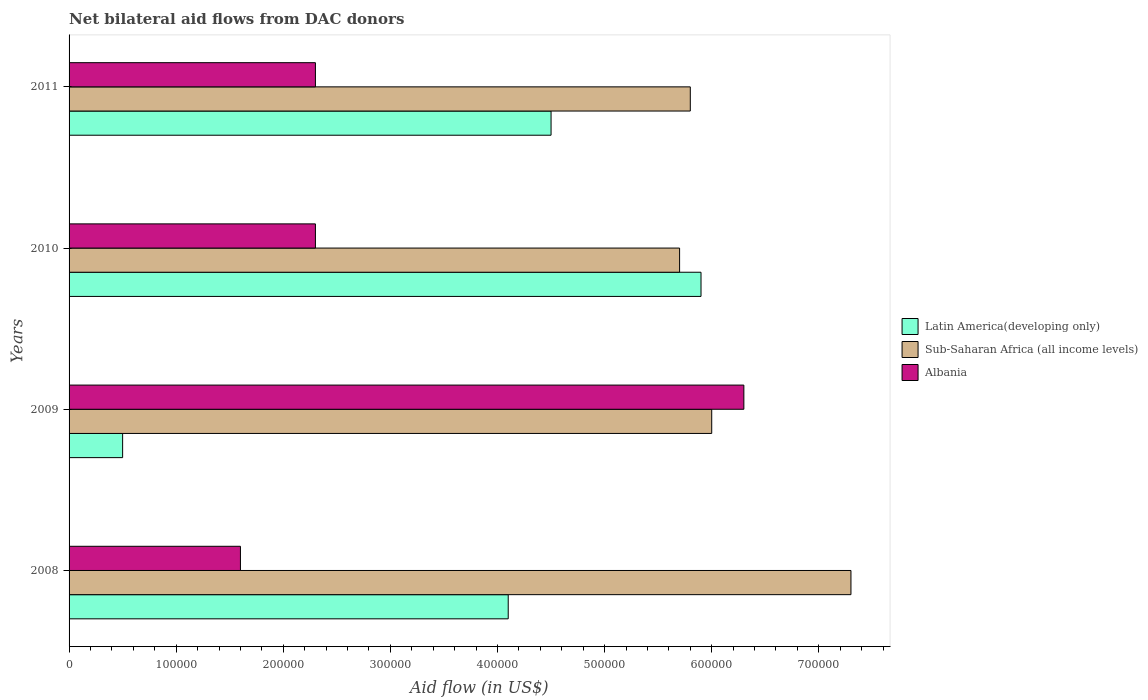Are the number of bars on each tick of the Y-axis equal?
Give a very brief answer. Yes. What is the label of the 2nd group of bars from the top?
Provide a succinct answer. 2010. What is the net bilateral aid flow in Latin America(developing only) in 2008?
Provide a succinct answer. 4.10e+05. Across all years, what is the maximum net bilateral aid flow in Latin America(developing only)?
Your answer should be compact. 5.90e+05. Across all years, what is the minimum net bilateral aid flow in Albania?
Provide a short and direct response. 1.60e+05. In which year was the net bilateral aid flow in Sub-Saharan Africa (all income levels) maximum?
Provide a short and direct response. 2008. What is the total net bilateral aid flow in Sub-Saharan Africa (all income levels) in the graph?
Offer a terse response. 2.48e+06. What is the difference between the net bilateral aid flow in Latin America(developing only) in 2008 and that in 2011?
Provide a short and direct response. -4.00e+04. What is the difference between the net bilateral aid flow in Latin America(developing only) in 2009 and the net bilateral aid flow in Albania in 2008?
Ensure brevity in your answer.  -1.10e+05. What is the average net bilateral aid flow in Sub-Saharan Africa (all income levels) per year?
Give a very brief answer. 6.20e+05. In the year 2008, what is the difference between the net bilateral aid flow in Latin America(developing only) and net bilateral aid flow in Albania?
Give a very brief answer. 2.50e+05. What is the ratio of the net bilateral aid flow in Latin America(developing only) in 2010 to that in 2011?
Offer a terse response. 1.31. Is the net bilateral aid flow in Albania in 2009 less than that in 2010?
Your answer should be very brief. No. Is the difference between the net bilateral aid flow in Latin America(developing only) in 2008 and 2010 greater than the difference between the net bilateral aid flow in Albania in 2008 and 2010?
Your response must be concise. No. What is the difference between the highest and the lowest net bilateral aid flow in Sub-Saharan Africa (all income levels)?
Your response must be concise. 1.60e+05. In how many years, is the net bilateral aid flow in Sub-Saharan Africa (all income levels) greater than the average net bilateral aid flow in Sub-Saharan Africa (all income levels) taken over all years?
Offer a terse response. 1. What does the 2nd bar from the top in 2008 represents?
Your answer should be compact. Sub-Saharan Africa (all income levels). What does the 3rd bar from the bottom in 2010 represents?
Your answer should be very brief. Albania. How many bars are there?
Your response must be concise. 12. Are all the bars in the graph horizontal?
Provide a short and direct response. Yes. Where does the legend appear in the graph?
Provide a succinct answer. Center right. What is the title of the graph?
Offer a terse response. Net bilateral aid flows from DAC donors. What is the label or title of the X-axis?
Offer a very short reply. Aid flow (in US$). What is the Aid flow (in US$) in Latin America(developing only) in 2008?
Ensure brevity in your answer.  4.10e+05. What is the Aid flow (in US$) in Sub-Saharan Africa (all income levels) in 2008?
Provide a succinct answer. 7.30e+05. What is the Aid flow (in US$) in Latin America(developing only) in 2009?
Make the answer very short. 5.00e+04. What is the Aid flow (in US$) in Sub-Saharan Africa (all income levels) in 2009?
Offer a terse response. 6.00e+05. What is the Aid flow (in US$) of Albania in 2009?
Ensure brevity in your answer.  6.30e+05. What is the Aid flow (in US$) of Latin America(developing only) in 2010?
Provide a succinct answer. 5.90e+05. What is the Aid flow (in US$) of Sub-Saharan Africa (all income levels) in 2010?
Offer a terse response. 5.70e+05. What is the Aid flow (in US$) of Sub-Saharan Africa (all income levels) in 2011?
Offer a terse response. 5.80e+05. What is the Aid flow (in US$) of Albania in 2011?
Your answer should be very brief. 2.30e+05. Across all years, what is the maximum Aid flow (in US$) of Latin America(developing only)?
Offer a very short reply. 5.90e+05. Across all years, what is the maximum Aid flow (in US$) in Sub-Saharan Africa (all income levels)?
Your response must be concise. 7.30e+05. Across all years, what is the maximum Aid flow (in US$) in Albania?
Ensure brevity in your answer.  6.30e+05. Across all years, what is the minimum Aid flow (in US$) in Sub-Saharan Africa (all income levels)?
Provide a short and direct response. 5.70e+05. Across all years, what is the minimum Aid flow (in US$) in Albania?
Your response must be concise. 1.60e+05. What is the total Aid flow (in US$) in Latin America(developing only) in the graph?
Make the answer very short. 1.50e+06. What is the total Aid flow (in US$) in Sub-Saharan Africa (all income levels) in the graph?
Make the answer very short. 2.48e+06. What is the total Aid flow (in US$) in Albania in the graph?
Make the answer very short. 1.25e+06. What is the difference between the Aid flow (in US$) of Latin America(developing only) in 2008 and that in 2009?
Give a very brief answer. 3.60e+05. What is the difference between the Aid flow (in US$) in Albania in 2008 and that in 2009?
Offer a terse response. -4.70e+05. What is the difference between the Aid flow (in US$) of Sub-Saharan Africa (all income levels) in 2008 and that in 2010?
Provide a succinct answer. 1.60e+05. What is the difference between the Aid flow (in US$) of Albania in 2008 and that in 2011?
Provide a short and direct response. -7.00e+04. What is the difference between the Aid flow (in US$) of Latin America(developing only) in 2009 and that in 2010?
Your answer should be compact. -5.40e+05. What is the difference between the Aid flow (in US$) in Albania in 2009 and that in 2010?
Make the answer very short. 4.00e+05. What is the difference between the Aid flow (in US$) of Latin America(developing only) in 2009 and that in 2011?
Provide a succinct answer. -4.00e+05. What is the difference between the Aid flow (in US$) of Sub-Saharan Africa (all income levels) in 2009 and that in 2011?
Your response must be concise. 2.00e+04. What is the difference between the Aid flow (in US$) in Albania in 2009 and that in 2011?
Provide a short and direct response. 4.00e+05. What is the difference between the Aid flow (in US$) of Latin America(developing only) in 2010 and that in 2011?
Keep it short and to the point. 1.40e+05. What is the difference between the Aid flow (in US$) in Sub-Saharan Africa (all income levels) in 2010 and that in 2011?
Offer a very short reply. -10000. What is the difference between the Aid flow (in US$) of Albania in 2010 and that in 2011?
Your answer should be very brief. 0. What is the difference between the Aid flow (in US$) of Sub-Saharan Africa (all income levels) in 2008 and the Aid flow (in US$) of Albania in 2009?
Make the answer very short. 1.00e+05. What is the difference between the Aid flow (in US$) in Latin America(developing only) in 2008 and the Aid flow (in US$) in Sub-Saharan Africa (all income levels) in 2010?
Provide a succinct answer. -1.60e+05. What is the difference between the Aid flow (in US$) in Sub-Saharan Africa (all income levels) in 2008 and the Aid flow (in US$) in Albania in 2010?
Give a very brief answer. 5.00e+05. What is the difference between the Aid flow (in US$) of Latin America(developing only) in 2008 and the Aid flow (in US$) of Albania in 2011?
Your response must be concise. 1.80e+05. What is the difference between the Aid flow (in US$) in Sub-Saharan Africa (all income levels) in 2008 and the Aid flow (in US$) in Albania in 2011?
Ensure brevity in your answer.  5.00e+05. What is the difference between the Aid flow (in US$) in Latin America(developing only) in 2009 and the Aid flow (in US$) in Sub-Saharan Africa (all income levels) in 2010?
Your response must be concise. -5.20e+05. What is the difference between the Aid flow (in US$) in Sub-Saharan Africa (all income levels) in 2009 and the Aid flow (in US$) in Albania in 2010?
Provide a succinct answer. 3.70e+05. What is the difference between the Aid flow (in US$) in Latin America(developing only) in 2009 and the Aid flow (in US$) in Sub-Saharan Africa (all income levels) in 2011?
Keep it short and to the point. -5.30e+05. What is the difference between the Aid flow (in US$) of Latin America(developing only) in 2009 and the Aid flow (in US$) of Albania in 2011?
Your answer should be very brief. -1.80e+05. What is the difference between the Aid flow (in US$) of Latin America(developing only) in 2010 and the Aid flow (in US$) of Sub-Saharan Africa (all income levels) in 2011?
Provide a succinct answer. 10000. What is the difference between the Aid flow (in US$) of Sub-Saharan Africa (all income levels) in 2010 and the Aid flow (in US$) of Albania in 2011?
Your answer should be compact. 3.40e+05. What is the average Aid flow (in US$) in Latin America(developing only) per year?
Offer a terse response. 3.75e+05. What is the average Aid flow (in US$) of Sub-Saharan Africa (all income levels) per year?
Your answer should be compact. 6.20e+05. What is the average Aid flow (in US$) in Albania per year?
Your answer should be compact. 3.12e+05. In the year 2008, what is the difference between the Aid flow (in US$) of Latin America(developing only) and Aid flow (in US$) of Sub-Saharan Africa (all income levels)?
Provide a succinct answer. -3.20e+05. In the year 2008, what is the difference between the Aid flow (in US$) of Sub-Saharan Africa (all income levels) and Aid flow (in US$) of Albania?
Your answer should be very brief. 5.70e+05. In the year 2009, what is the difference between the Aid flow (in US$) in Latin America(developing only) and Aid flow (in US$) in Sub-Saharan Africa (all income levels)?
Give a very brief answer. -5.50e+05. In the year 2009, what is the difference between the Aid flow (in US$) of Latin America(developing only) and Aid flow (in US$) of Albania?
Provide a short and direct response. -5.80e+05. In the year 2011, what is the difference between the Aid flow (in US$) in Latin America(developing only) and Aid flow (in US$) in Sub-Saharan Africa (all income levels)?
Your answer should be very brief. -1.30e+05. In the year 2011, what is the difference between the Aid flow (in US$) in Latin America(developing only) and Aid flow (in US$) in Albania?
Your answer should be very brief. 2.20e+05. In the year 2011, what is the difference between the Aid flow (in US$) of Sub-Saharan Africa (all income levels) and Aid flow (in US$) of Albania?
Ensure brevity in your answer.  3.50e+05. What is the ratio of the Aid flow (in US$) in Sub-Saharan Africa (all income levels) in 2008 to that in 2009?
Give a very brief answer. 1.22. What is the ratio of the Aid flow (in US$) of Albania in 2008 to that in 2009?
Make the answer very short. 0.25. What is the ratio of the Aid flow (in US$) of Latin America(developing only) in 2008 to that in 2010?
Offer a very short reply. 0.69. What is the ratio of the Aid flow (in US$) of Sub-Saharan Africa (all income levels) in 2008 to that in 2010?
Give a very brief answer. 1.28. What is the ratio of the Aid flow (in US$) in Albania in 2008 to that in 2010?
Your response must be concise. 0.7. What is the ratio of the Aid flow (in US$) in Latin America(developing only) in 2008 to that in 2011?
Your answer should be compact. 0.91. What is the ratio of the Aid flow (in US$) in Sub-Saharan Africa (all income levels) in 2008 to that in 2011?
Your response must be concise. 1.26. What is the ratio of the Aid flow (in US$) of Albania in 2008 to that in 2011?
Provide a short and direct response. 0.7. What is the ratio of the Aid flow (in US$) in Latin America(developing only) in 2009 to that in 2010?
Keep it short and to the point. 0.08. What is the ratio of the Aid flow (in US$) of Sub-Saharan Africa (all income levels) in 2009 to that in 2010?
Keep it short and to the point. 1.05. What is the ratio of the Aid flow (in US$) of Albania in 2009 to that in 2010?
Your response must be concise. 2.74. What is the ratio of the Aid flow (in US$) in Sub-Saharan Africa (all income levels) in 2009 to that in 2011?
Ensure brevity in your answer.  1.03. What is the ratio of the Aid flow (in US$) of Albania in 2009 to that in 2011?
Provide a short and direct response. 2.74. What is the ratio of the Aid flow (in US$) in Latin America(developing only) in 2010 to that in 2011?
Your answer should be very brief. 1.31. What is the ratio of the Aid flow (in US$) in Sub-Saharan Africa (all income levels) in 2010 to that in 2011?
Give a very brief answer. 0.98. What is the ratio of the Aid flow (in US$) in Albania in 2010 to that in 2011?
Provide a succinct answer. 1. What is the difference between the highest and the second highest Aid flow (in US$) in Albania?
Your answer should be very brief. 4.00e+05. What is the difference between the highest and the lowest Aid flow (in US$) in Latin America(developing only)?
Your answer should be compact. 5.40e+05. What is the difference between the highest and the lowest Aid flow (in US$) of Sub-Saharan Africa (all income levels)?
Your response must be concise. 1.60e+05. 